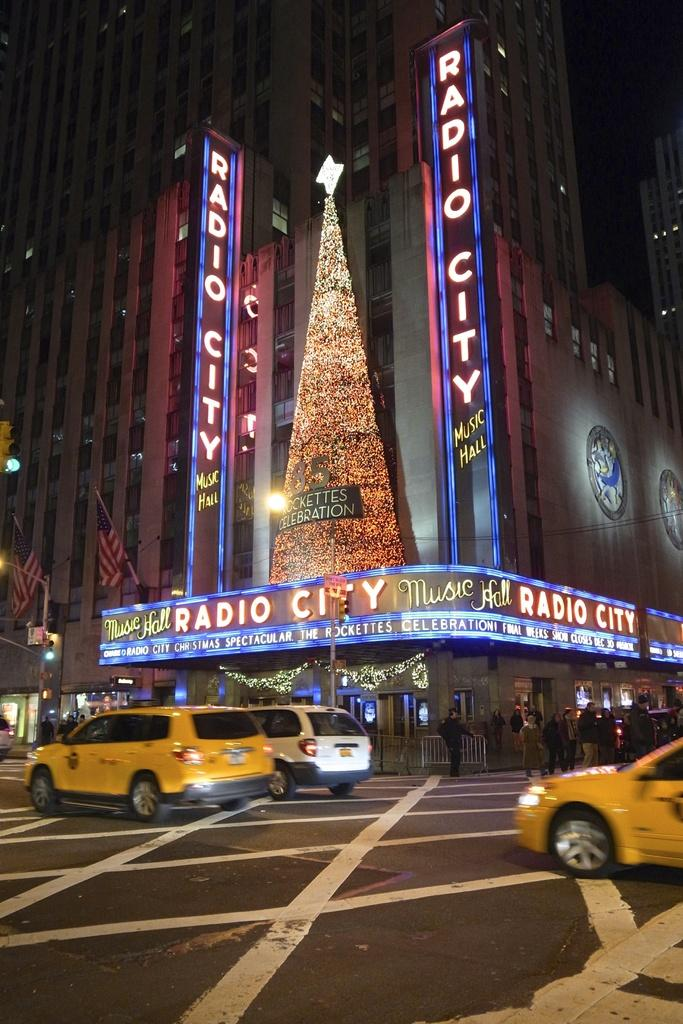<image>
Provide a brief description of the given image. Night time outside Radio City Music Hall in new york city. 